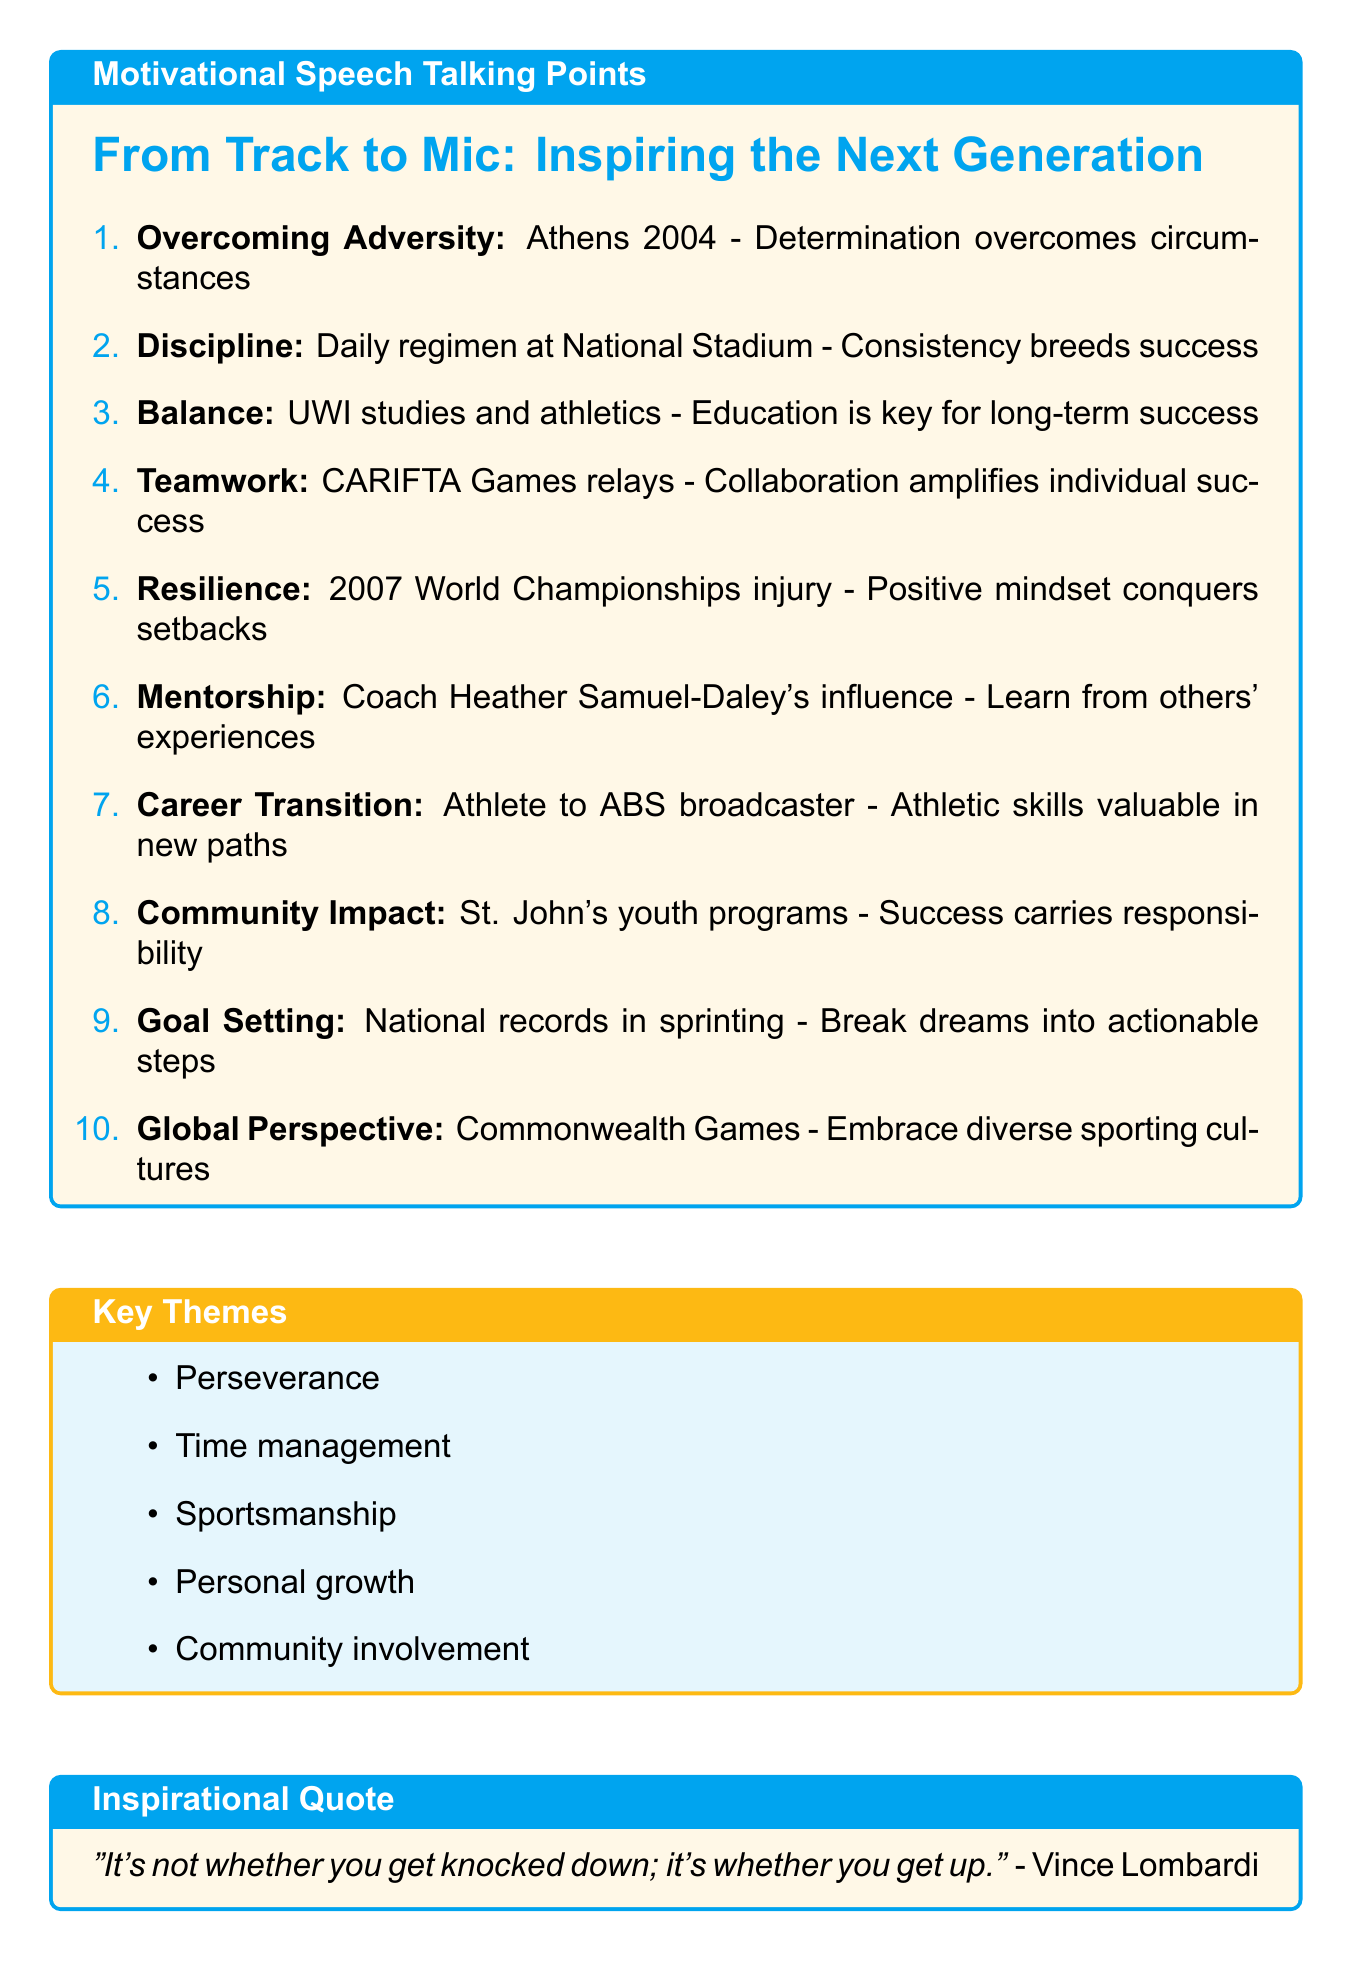What is the title of the first talking point? The title of the first talking point is "Overcoming Adversity," which addresses personal experiences and challenges faced.
Answer: Overcoming Adversity Which Olympic Games did the athlete qualify for? The document mentions qualifying for the Athens 2004 Olympics, highlighting a significant achievement.
Answer: Athens 2004 What is one key theme listed in the document? The document lists several key themes, one of which is "Perseverance," emphasizing the importance of continuing through difficulties.
Answer: Perseverance Who is mentioned as a mentor in the speech? The speech refers to coach Heather Samuel-Daley as a significant influence in the athlete's career, showcasing the role of mentorship.
Answer: Heather Samuel-Daley What is one of the inspirational quotes provided? The document includes multiple quotes, one of which emphasizes resilience: "It's not whether you get knocked down; it's whether you get up."
Answer: It's not whether you get knocked down; it's whether you get up What type of demonstration is included as an interactive element? The document mentions a "Quick sprinting technique demonstration" as one of the interactive elements intended to engage students.
Answer: Quick sprinting technique demonstration How many talking points are listed in the document? The document outlines ten talking points, each focusing on different aspects of the athlete's experiences and lessons learned.
Answer: Ten What competition is specifically mentioned in relation to teamwork? The CARIFTA Games is highlighted in the document as a specific event where teamwork was experienced, particularly in relay events.
Answer: CARIFTA Games What responsibility comes with success, according to the talking points? The document states that with success comes the responsibility to inspire and support the next generation, emphasizing community involvement.
Answer: Inspire and support the next generation What is the purpose of the goal-setting worksheet mentioned? The goal-setting worksheet is designed to help attendees break down their ambitions into actionable steps, facilitating personal development.
Answer: Break down big dreams into actionable steps 